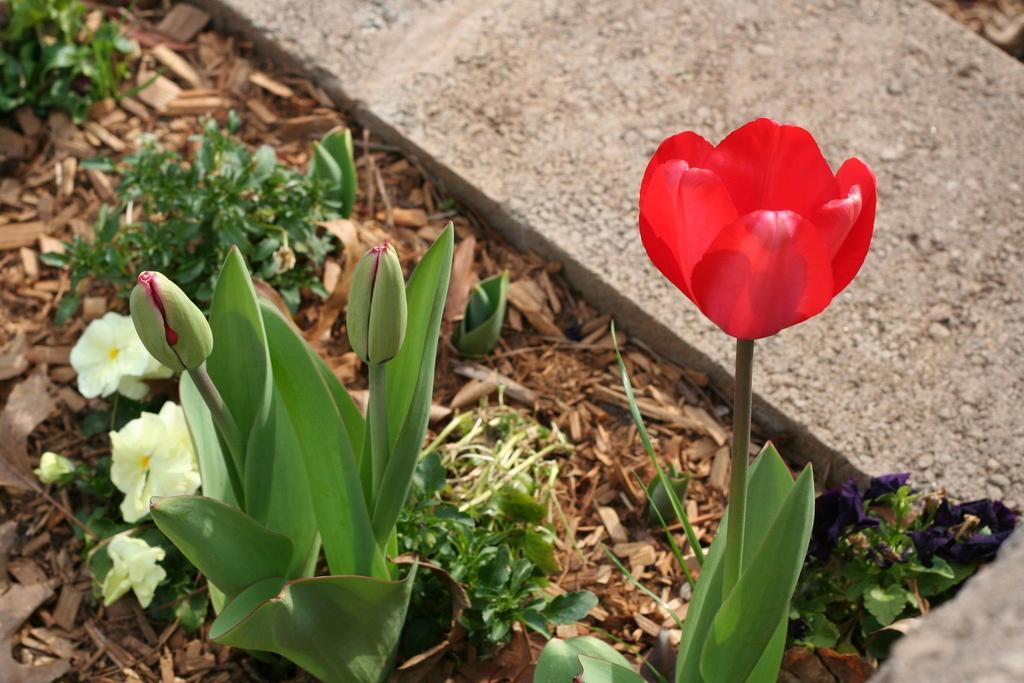What is the main subject in the center of the image? There are plants in the center of the image. What else can be seen in the image besides the plants? Dry leaves and a stone are present in the image. What type of plants are featured in the image? There are flowers in the image. What colors are the flowers? The flowers are in light yellow and red colors. What is the artist's opinion on the snail in the image? There is no snail present in the image, and therefore no artist's opinion can be determined. 